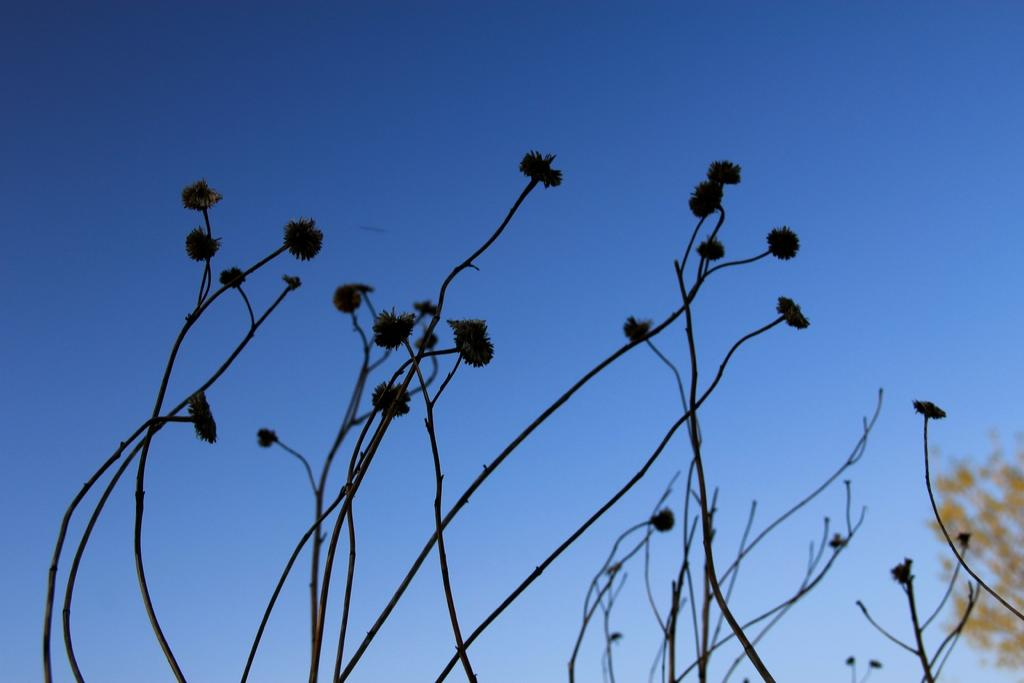What type of plant parts can be seen in the image? There are stems in the image. What is attached to the stems in the image? There are flowers in the image. What is visible at the top of the image? The sky is visible at the top of the image. What is the color of the sky in the image? The color of the sky is blue. Is there a volcano erupting in the image? No, there is no volcano present in the image. Can you see a parcel being delivered in the image? No, there is no parcel or delivery activity depicted in the image. 